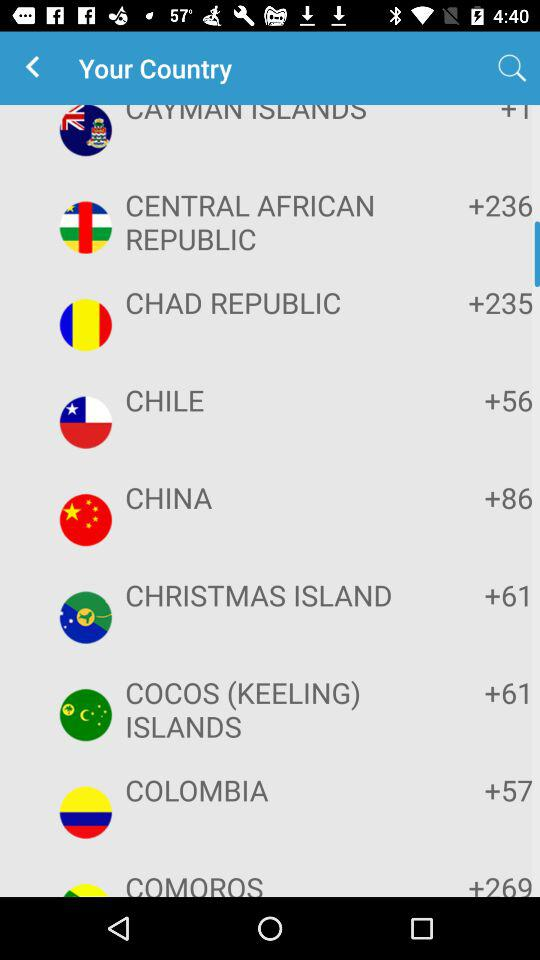What is the code of China? The code is +86. 